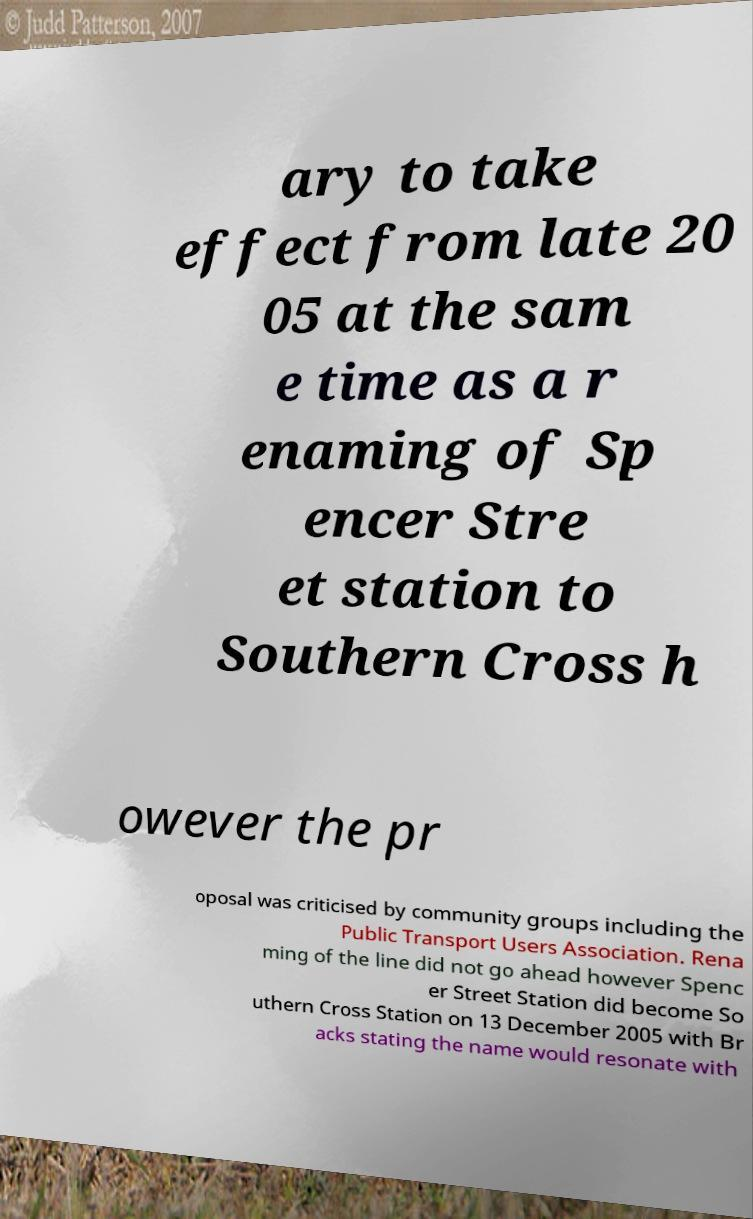I need the written content from this picture converted into text. Can you do that? ary to take effect from late 20 05 at the sam e time as a r enaming of Sp encer Stre et station to Southern Cross h owever the pr oposal was criticised by community groups including the Public Transport Users Association. Rena ming of the line did not go ahead however Spenc er Street Station did become So uthern Cross Station on 13 December 2005 with Br acks stating the name would resonate with 